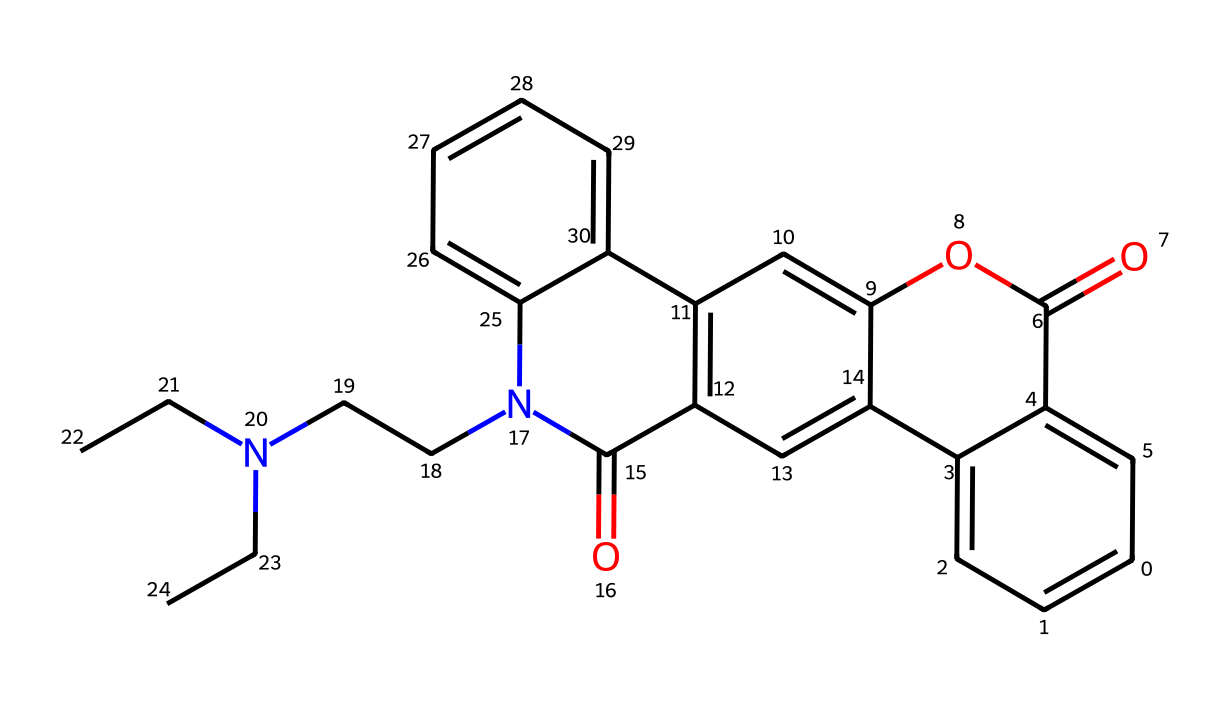What is the molecular weight of the compound? To determine the molecular weight, we identify each atom in the SMILES representation: the structure includes carbon (C), hydrogen (H), nitrogen (N), and oxygen (O). By calculating the total weight from the individual atomic weights (C = 12.01, H = 1.008, N = 14.01, O = 16.00), we arrive at the total molecular weight.
Answer: approximately 365.44 g/mol How many nitrogen atoms are present? We need to count the nitrogen (N) atoms represented in the chemical structure encoded in the SMILES. There are two nitrogen atoms noted in the structure.
Answer: 2 What functional group is represented by the "C(=O)" sequence? The "C(=O)" indicates a carbonyl functional group, specifically a ketone or an amide depending on the context of its attachment in the molecule. In this structure, it is part of an amide functional group due to the nitrogen linkage.
Answer: amide What is the predominant type of bonding present in this molecule? By examining the structure, we observe the presence of covalent bonds particularly associated with the carbon atoms, as they form chains and rings. Given the organic nature of the compound, covalent bonding is the primary type of bonding exhibited.
Answer: covalent Does the structure suggest any aromatic characteristics? Analyzing the SMILES reveals multiple aromatic rings indicated by the lowercase 'c' in the representation, suggesting that the compound features aromatic properties inherent in its cyclic structures.
Answer: yes 